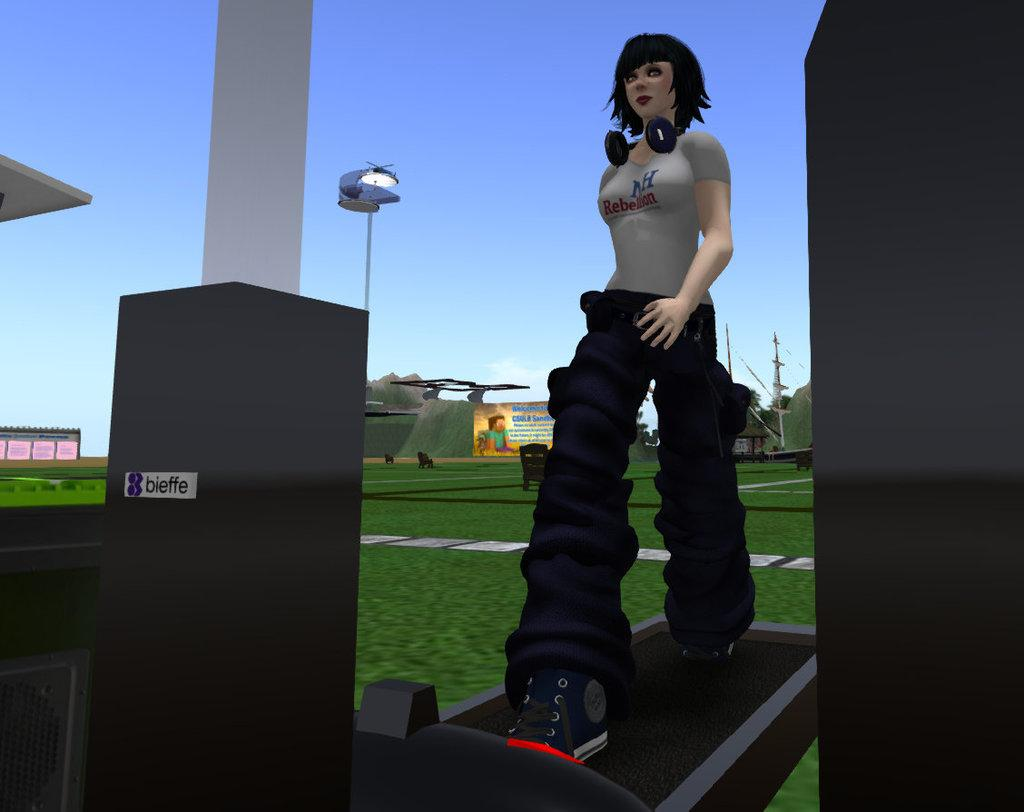What type of image is being described? The image is graphical. Who or what is depicted in the image? There is a woman in the image. What type of natural environment is visible in the image? There is grass in the image. What man-made structures are present in the image? There are poles and banners in the image. What part of the natural environment is visible in the image? The sky is visible in the image. What verse is the writer reciting in the image? There is no writer or verse present in the image; it features a woman, grass, poles, banners, and the sky. What type of metal is used to construct the poles in the image? There is no information about the material used to construct the poles in the image. 